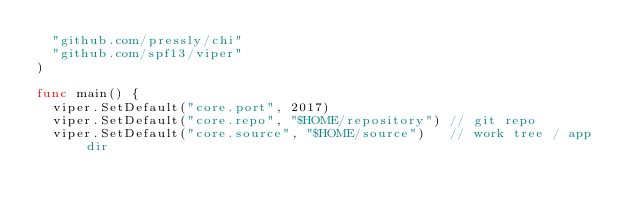Convert code to text. <code><loc_0><loc_0><loc_500><loc_500><_Go_>	"github.com/pressly/chi"
	"github.com/spf13/viper"
)

func main() {
	viper.SetDefault("core.port", 2017)
	viper.SetDefault("core.repo", "$HOME/repository") // git repo
	viper.SetDefault("core.source", "$HOME/source")   // work tree / app dir</code> 